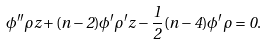<formula> <loc_0><loc_0><loc_500><loc_500>\phi ^ { \prime \prime } \rho z + ( n - 2 ) \phi ^ { \prime } \rho ^ { \prime } z - \frac { 1 } { 2 } \, ( n - 4 ) \phi ^ { \prime } \rho = 0 .</formula> 